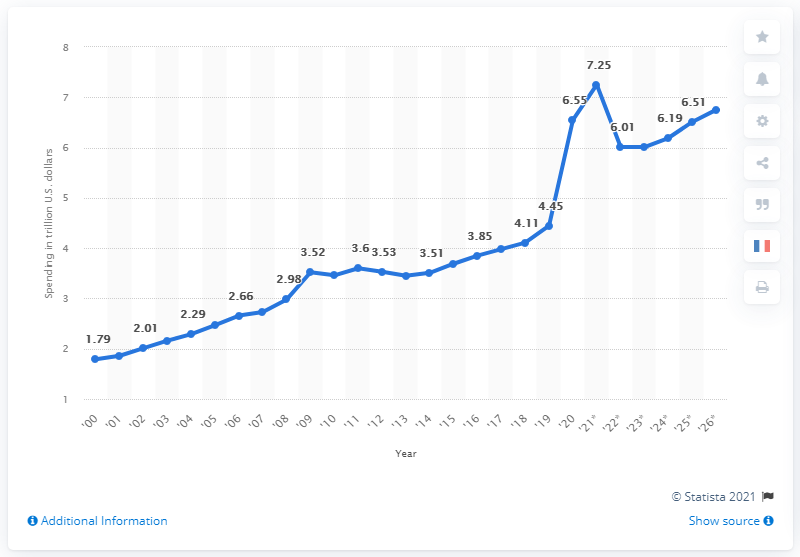Identify some key points in this picture. In 2020, the U.S. government spent approximately 6.51 trillion dollars. By 2026, the U.S. government is projected to spend approximately $6.75 trillion. 